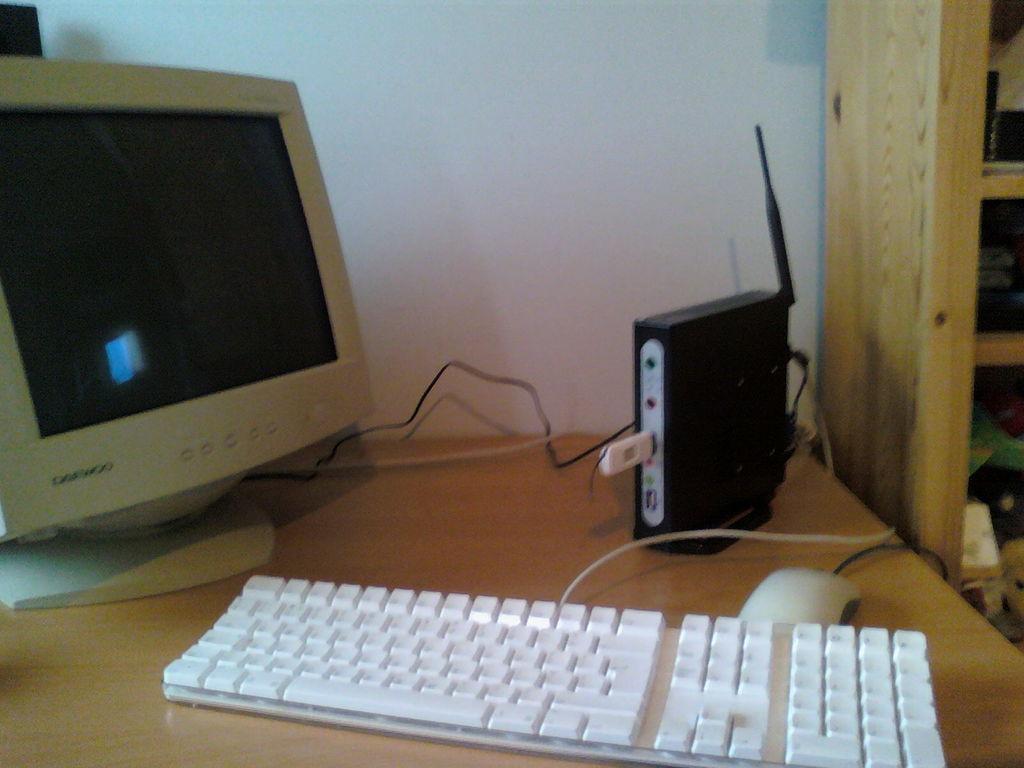Describe this image in one or two sentences. We can see monitor,electrical device,keyboard,mouse on the table. On the background we can see wall,furniture. 